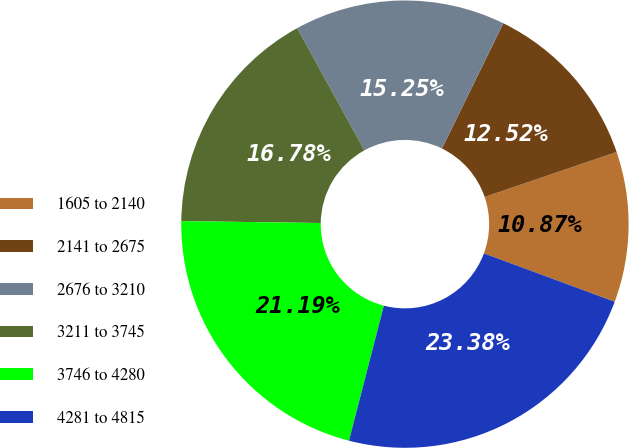<chart> <loc_0><loc_0><loc_500><loc_500><pie_chart><fcel>1605 to 2140<fcel>2141 to 2675<fcel>2676 to 3210<fcel>3211 to 3745<fcel>3746 to 4280<fcel>4281 to 4815<nl><fcel>10.87%<fcel>12.52%<fcel>15.25%<fcel>16.78%<fcel>21.19%<fcel>23.38%<nl></chart> 